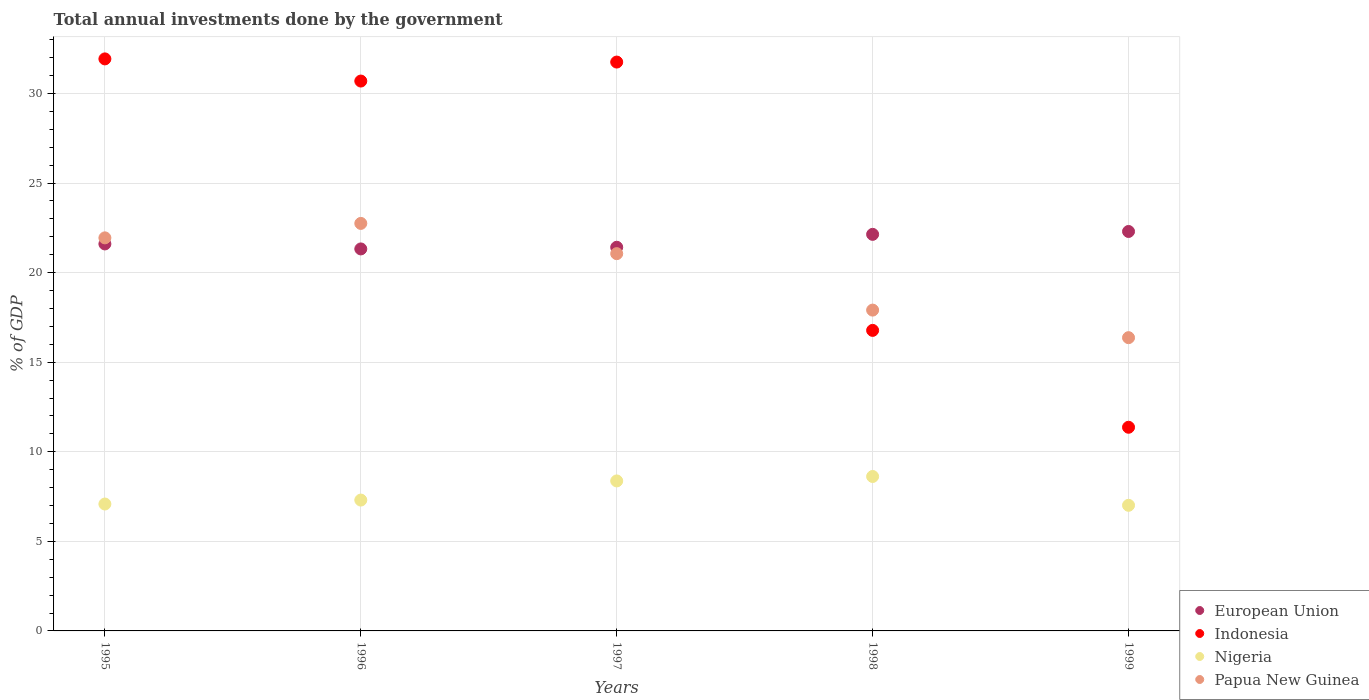How many different coloured dotlines are there?
Your answer should be compact. 4. What is the total annual investments done by the government in Indonesia in 1999?
Offer a terse response. 11.37. Across all years, what is the maximum total annual investments done by the government in European Union?
Offer a terse response. 22.3. Across all years, what is the minimum total annual investments done by the government in Nigeria?
Give a very brief answer. 7.01. In which year was the total annual investments done by the government in Papua New Guinea maximum?
Offer a terse response. 1996. In which year was the total annual investments done by the government in Papua New Guinea minimum?
Provide a short and direct response. 1999. What is the total total annual investments done by the government in Indonesia in the graph?
Your response must be concise. 122.51. What is the difference between the total annual investments done by the government in Papua New Guinea in 1996 and that in 1998?
Make the answer very short. 4.84. What is the difference between the total annual investments done by the government in European Union in 1995 and the total annual investments done by the government in Nigeria in 1999?
Your answer should be compact. 14.59. What is the average total annual investments done by the government in Nigeria per year?
Provide a short and direct response. 7.68. In the year 1996, what is the difference between the total annual investments done by the government in European Union and total annual investments done by the government in Nigeria?
Offer a terse response. 14.02. What is the ratio of the total annual investments done by the government in Indonesia in 1997 to that in 1998?
Offer a terse response. 1.89. Is the difference between the total annual investments done by the government in European Union in 1995 and 1997 greater than the difference between the total annual investments done by the government in Nigeria in 1995 and 1997?
Give a very brief answer. Yes. What is the difference between the highest and the second highest total annual investments done by the government in Indonesia?
Give a very brief answer. 0.18. What is the difference between the highest and the lowest total annual investments done by the government in Indonesia?
Give a very brief answer. 20.56. In how many years, is the total annual investments done by the government in European Union greater than the average total annual investments done by the government in European Union taken over all years?
Provide a succinct answer. 2. Is it the case that in every year, the sum of the total annual investments done by the government in Indonesia and total annual investments done by the government in Papua New Guinea  is greater than the total annual investments done by the government in European Union?
Your answer should be very brief. Yes. Does the total annual investments done by the government in European Union monotonically increase over the years?
Ensure brevity in your answer.  No. Is the total annual investments done by the government in European Union strictly greater than the total annual investments done by the government in Nigeria over the years?
Offer a terse response. Yes. Is the total annual investments done by the government in Indonesia strictly less than the total annual investments done by the government in Nigeria over the years?
Make the answer very short. No. How many dotlines are there?
Offer a terse response. 4. How many years are there in the graph?
Provide a short and direct response. 5. What is the difference between two consecutive major ticks on the Y-axis?
Your answer should be very brief. 5. Where does the legend appear in the graph?
Make the answer very short. Bottom right. What is the title of the graph?
Offer a terse response. Total annual investments done by the government. Does "Brunei Darussalam" appear as one of the legend labels in the graph?
Make the answer very short. No. What is the label or title of the Y-axis?
Your answer should be compact. % of GDP. What is the % of GDP in European Union in 1995?
Give a very brief answer. 21.6. What is the % of GDP in Indonesia in 1995?
Keep it short and to the point. 31.93. What is the % of GDP of Nigeria in 1995?
Keep it short and to the point. 7.08. What is the % of GDP of Papua New Guinea in 1995?
Give a very brief answer. 21.94. What is the % of GDP in European Union in 1996?
Your response must be concise. 21.32. What is the % of GDP of Indonesia in 1996?
Offer a terse response. 30.69. What is the % of GDP of Nigeria in 1996?
Keep it short and to the point. 7.3. What is the % of GDP in Papua New Guinea in 1996?
Your answer should be very brief. 22.75. What is the % of GDP in European Union in 1997?
Your answer should be compact. 21.41. What is the % of GDP in Indonesia in 1997?
Make the answer very short. 31.75. What is the % of GDP of Nigeria in 1997?
Offer a terse response. 8.37. What is the % of GDP in Papua New Guinea in 1997?
Make the answer very short. 21.06. What is the % of GDP in European Union in 1998?
Your answer should be very brief. 22.13. What is the % of GDP of Indonesia in 1998?
Provide a succinct answer. 16.77. What is the % of GDP in Nigeria in 1998?
Give a very brief answer. 8.62. What is the % of GDP of Papua New Guinea in 1998?
Offer a very short reply. 17.91. What is the % of GDP of European Union in 1999?
Give a very brief answer. 22.3. What is the % of GDP of Indonesia in 1999?
Keep it short and to the point. 11.37. What is the % of GDP of Nigeria in 1999?
Offer a very short reply. 7.01. What is the % of GDP of Papua New Guinea in 1999?
Keep it short and to the point. 16.37. Across all years, what is the maximum % of GDP of European Union?
Make the answer very short. 22.3. Across all years, what is the maximum % of GDP in Indonesia?
Provide a succinct answer. 31.93. Across all years, what is the maximum % of GDP of Nigeria?
Your answer should be compact. 8.62. Across all years, what is the maximum % of GDP of Papua New Guinea?
Ensure brevity in your answer.  22.75. Across all years, what is the minimum % of GDP of European Union?
Give a very brief answer. 21.32. Across all years, what is the minimum % of GDP in Indonesia?
Make the answer very short. 11.37. Across all years, what is the minimum % of GDP of Nigeria?
Offer a very short reply. 7.01. Across all years, what is the minimum % of GDP of Papua New Guinea?
Ensure brevity in your answer.  16.37. What is the total % of GDP of European Union in the graph?
Make the answer very short. 108.77. What is the total % of GDP of Indonesia in the graph?
Provide a succinct answer. 122.51. What is the total % of GDP in Nigeria in the graph?
Give a very brief answer. 38.39. What is the total % of GDP of Papua New Guinea in the graph?
Provide a short and direct response. 100.02. What is the difference between the % of GDP of European Union in 1995 and that in 1996?
Offer a terse response. 0.28. What is the difference between the % of GDP in Indonesia in 1995 and that in 1996?
Offer a very short reply. 1.24. What is the difference between the % of GDP of Nigeria in 1995 and that in 1996?
Ensure brevity in your answer.  -0.22. What is the difference between the % of GDP in Papua New Guinea in 1995 and that in 1996?
Provide a short and direct response. -0.81. What is the difference between the % of GDP in European Union in 1995 and that in 1997?
Offer a very short reply. 0.19. What is the difference between the % of GDP in Indonesia in 1995 and that in 1997?
Offer a terse response. 0.18. What is the difference between the % of GDP of Nigeria in 1995 and that in 1997?
Keep it short and to the point. -1.29. What is the difference between the % of GDP in Papua New Guinea in 1995 and that in 1997?
Give a very brief answer. 0.88. What is the difference between the % of GDP of European Union in 1995 and that in 1998?
Give a very brief answer. -0.53. What is the difference between the % of GDP in Indonesia in 1995 and that in 1998?
Make the answer very short. 15.15. What is the difference between the % of GDP in Nigeria in 1995 and that in 1998?
Provide a short and direct response. -1.54. What is the difference between the % of GDP in Papua New Guinea in 1995 and that in 1998?
Your answer should be very brief. 4.03. What is the difference between the % of GDP in European Union in 1995 and that in 1999?
Your response must be concise. -0.7. What is the difference between the % of GDP of Indonesia in 1995 and that in 1999?
Provide a short and direct response. 20.56. What is the difference between the % of GDP in Nigeria in 1995 and that in 1999?
Offer a terse response. 0.07. What is the difference between the % of GDP in Papua New Guinea in 1995 and that in 1999?
Give a very brief answer. 5.57. What is the difference between the % of GDP in European Union in 1996 and that in 1997?
Your response must be concise. -0.09. What is the difference between the % of GDP in Indonesia in 1996 and that in 1997?
Your answer should be compact. -1.06. What is the difference between the % of GDP of Nigeria in 1996 and that in 1997?
Your response must be concise. -1.07. What is the difference between the % of GDP of Papua New Guinea in 1996 and that in 1997?
Provide a short and direct response. 1.69. What is the difference between the % of GDP in European Union in 1996 and that in 1998?
Keep it short and to the point. -0.81. What is the difference between the % of GDP of Indonesia in 1996 and that in 1998?
Make the answer very short. 13.92. What is the difference between the % of GDP in Nigeria in 1996 and that in 1998?
Make the answer very short. -1.32. What is the difference between the % of GDP of Papua New Guinea in 1996 and that in 1998?
Provide a succinct answer. 4.84. What is the difference between the % of GDP in European Union in 1996 and that in 1999?
Provide a short and direct response. -0.97. What is the difference between the % of GDP in Indonesia in 1996 and that in 1999?
Make the answer very short. 19.32. What is the difference between the % of GDP in Nigeria in 1996 and that in 1999?
Keep it short and to the point. 0.29. What is the difference between the % of GDP of Papua New Guinea in 1996 and that in 1999?
Offer a terse response. 6.38. What is the difference between the % of GDP in European Union in 1997 and that in 1998?
Your answer should be compact. -0.72. What is the difference between the % of GDP of Indonesia in 1997 and that in 1998?
Offer a very short reply. 14.98. What is the difference between the % of GDP in Nigeria in 1997 and that in 1998?
Ensure brevity in your answer.  -0.25. What is the difference between the % of GDP in Papua New Guinea in 1997 and that in 1998?
Give a very brief answer. 3.15. What is the difference between the % of GDP in European Union in 1997 and that in 1999?
Your response must be concise. -0.88. What is the difference between the % of GDP in Indonesia in 1997 and that in 1999?
Your response must be concise. 20.38. What is the difference between the % of GDP in Nigeria in 1997 and that in 1999?
Your answer should be compact. 1.36. What is the difference between the % of GDP of Papua New Guinea in 1997 and that in 1999?
Make the answer very short. 4.69. What is the difference between the % of GDP of European Union in 1998 and that in 1999?
Offer a very short reply. -0.16. What is the difference between the % of GDP of Indonesia in 1998 and that in 1999?
Make the answer very short. 5.41. What is the difference between the % of GDP in Nigeria in 1998 and that in 1999?
Provide a short and direct response. 1.61. What is the difference between the % of GDP of Papua New Guinea in 1998 and that in 1999?
Ensure brevity in your answer.  1.54. What is the difference between the % of GDP in European Union in 1995 and the % of GDP in Indonesia in 1996?
Make the answer very short. -9.09. What is the difference between the % of GDP in European Union in 1995 and the % of GDP in Nigeria in 1996?
Offer a very short reply. 14.3. What is the difference between the % of GDP in European Union in 1995 and the % of GDP in Papua New Guinea in 1996?
Ensure brevity in your answer.  -1.15. What is the difference between the % of GDP of Indonesia in 1995 and the % of GDP of Nigeria in 1996?
Keep it short and to the point. 24.62. What is the difference between the % of GDP of Indonesia in 1995 and the % of GDP of Papua New Guinea in 1996?
Your answer should be very brief. 9.18. What is the difference between the % of GDP of Nigeria in 1995 and the % of GDP of Papua New Guinea in 1996?
Provide a short and direct response. -15.66. What is the difference between the % of GDP of European Union in 1995 and the % of GDP of Indonesia in 1997?
Your answer should be compact. -10.15. What is the difference between the % of GDP in European Union in 1995 and the % of GDP in Nigeria in 1997?
Keep it short and to the point. 13.23. What is the difference between the % of GDP of European Union in 1995 and the % of GDP of Papua New Guinea in 1997?
Keep it short and to the point. 0.54. What is the difference between the % of GDP in Indonesia in 1995 and the % of GDP in Nigeria in 1997?
Ensure brevity in your answer.  23.56. What is the difference between the % of GDP of Indonesia in 1995 and the % of GDP of Papua New Guinea in 1997?
Your answer should be compact. 10.87. What is the difference between the % of GDP of Nigeria in 1995 and the % of GDP of Papua New Guinea in 1997?
Keep it short and to the point. -13.97. What is the difference between the % of GDP of European Union in 1995 and the % of GDP of Indonesia in 1998?
Keep it short and to the point. 4.82. What is the difference between the % of GDP of European Union in 1995 and the % of GDP of Nigeria in 1998?
Give a very brief answer. 12.98. What is the difference between the % of GDP in European Union in 1995 and the % of GDP in Papua New Guinea in 1998?
Offer a very short reply. 3.69. What is the difference between the % of GDP of Indonesia in 1995 and the % of GDP of Nigeria in 1998?
Provide a short and direct response. 23.31. What is the difference between the % of GDP of Indonesia in 1995 and the % of GDP of Papua New Guinea in 1998?
Your answer should be compact. 14.02. What is the difference between the % of GDP of Nigeria in 1995 and the % of GDP of Papua New Guinea in 1998?
Your answer should be very brief. -10.82. What is the difference between the % of GDP of European Union in 1995 and the % of GDP of Indonesia in 1999?
Provide a succinct answer. 10.23. What is the difference between the % of GDP of European Union in 1995 and the % of GDP of Nigeria in 1999?
Your answer should be very brief. 14.59. What is the difference between the % of GDP of European Union in 1995 and the % of GDP of Papua New Guinea in 1999?
Offer a terse response. 5.23. What is the difference between the % of GDP in Indonesia in 1995 and the % of GDP in Nigeria in 1999?
Your answer should be very brief. 24.92. What is the difference between the % of GDP in Indonesia in 1995 and the % of GDP in Papua New Guinea in 1999?
Give a very brief answer. 15.56. What is the difference between the % of GDP of Nigeria in 1995 and the % of GDP of Papua New Guinea in 1999?
Offer a very short reply. -9.29. What is the difference between the % of GDP in European Union in 1996 and the % of GDP in Indonesia in 1997?
Offer a very short reply. -10.43. What is the difference between the % of GDP of European Union in 1996 and the % of GDP of Nigeria in 1997?
Offer a terse response. 12.95. What is the difference between the % of GDP of European Union in 1996 and the % of GDP of Papua New Guinea in 1997?
Ensure brevity in your answer.  0.26. What is the difference between the % of GDP of Indonesia in 1996 and the % of GDP of Nigeria in 1997?
Your answer should be compact. 22.32. What is the difference between the % of GDP of Indonesia in 1996 and the % of GDP of Papua New Guinea in 1997?
Make the answer very short. 9.63. What is the difference between the % of GDP of Nigeria in 1996 and the % of GDP of Papua New Guinea in 1997?
Make the answer very short. -13.75. What is the difference between the % of GDP in European Union in 1996 and the % of GDP in Indonesia in 1998?
Ensure brevity in your answer.  4.55. What is the difference between the % of GDP of European Union in 1996 and the % of GDP of Nigeria in 1998?
Provide a short and direct response. 12.7. What is the difference between the % of GDP in European Union in 1996 and the % of GDP in Papua New Guinea in 1998?
Your response must be concise. 3.41. What is the difference between the % of GDP in Indonesia in 1996 and the % of GDP in Nigeria in 1998?
Your response must be concise. 22.07. What is the difference between the % of GDP in Indonesia in 1996 and the % of GDP in Papua New Guinea in 1998?
Provide a short and direct response. 12.78. What is the difference between the % of GDP in Nigeria in 1996 and the % of GDP in Papua New Guinea in 1998?
Give a very brief answer. -10.6. What is the difference between the % of GDP in European Union in 1996 and the % of GDP in Indonesia in 1999?
Offer a very short reply. 9.95. What is the difference between the % of GDP in European Union in 1996 and the % of GDP in Nigeria in 1999?
Provide a succinct answer. 14.31. What is the difference between the % of GDP of European Union in 1996 and the % of GDP of Papua New Guinea in 1999?
Make the answer very short. 4.95. What is the difference between the % of GDP of Indonesia in 1996 and the % of GDP of Nigeria in 1999?
Your answer should be very brief. 23.68. What is the difference between the % of GDP in Indonesia in 1996 and the % of GDP in Papua New Guinea in 1999?
Offer a terse response. 14.32. What is the difference between the % of GDP in Nigeria in 1996 and the % of GDP in Papua New Guinea in 1999?
Your answer should be compact. -9.06. What is the difference between the % of GDP of European Union in 1997 and the % of GDP of Indonesia in 1998?
Your answer should be compact. 4.64. What is the difference between the % of GDP of European Union in 1997 and the % of GDP of Nigeria in 1998?
Your answer should be compact. 12.79. What is the difference between the % of GDP in European Union in 1997 and the % of GDP in Papua New Guinea in 1998?
Make the answer very short. 3.51. What is the difference between the % of GDP in Indonesia in 1997 and the % of GDP in Nigeria in 1998?
Make the answer very short. 23.13. What is the difference between the % of GDP in Indonesia in 1997 and the % of GDP in Papua New Guinea in 1998?
Your answer should be compact. 13.84. What is the difference between the % of GDP of Nigeria in 1997 and the % of GDP of Papua New Guinea in 1998?
Keep it short and to the point. -9.53. What is the difference between the % of GDP of European Union in 1997 and the % of GDP of Indonesia in 1999?
Offer a terse response. 10.05. What is the difference between the % of GDP of European Union in 1997 and the % of GDP of Nigeria in 1999?
Your answer should be very brief. 14.4. What is the difference between the % of GDP in European Union in 1997 and the % of GDP in Papua New Guinea in 1999?
Your response must be concise. 5.05. What is the difference between the % of GDP of Indonesia in 1997 and the % of GDP of Nigeria in 1999?
Offer a very short reply. 24.74. What is the difference between the % of GDP in Indonesia in 1997 and the % of GDP in Papua New Guinea in 1999?
Offer a very short reply. 15.38. What is the difference between the % of GDP of Nigeria in 1997 and the % of GDP of Papua New Guinea in 1999?
Your response must be concise. -8. What is the difference between the % of GDP in European Union in 1998 and the % of GDP in Indonesia in 1999?
Provide a succinct answer. 10.77. What is the difference between the % of GDP in European Union in 1998 and the % of GDP in Nigeria in 1999?
Offer a very short reply. 15.12. What is the difference between the % of GDP of European Union in 1998 and the % of GDP of Papua New Guinea in 1999?
Give a very brief answer. 5.77. What is the difference between the % of GDP of Indonesia in 1998 and the % of GDP of Nigeria in 1999?
Ensure brevity in your answer.  9.76. What is the difference between the % of GDP in Indonesia in 1998 and the % of GDP in Papua New Guinea in 1999?
Give a very brief answer. 0.41. What is the difference between the % of GDP of Nigeria in 1998 and the % of GDP of Papua New Guinea in 1999?
Ensure brevity in your answer.  -7.75. What is the average % of GDP in European Union per year?
Your response must be concise. 21.75. What is the average % of GDP in Indonesia per year?
Make the answer very short. 24.5. What is the average % of GDP of Nigeria per year?
Provide a succinct answer. 7.68. What is the average % of GDP in Papua New Guinea per year?
Offer a very short reply. 20. In the year 1995, what is the difference between the % of GDP of European Union and % of GDP of Indonesia?
Offer a very short reply. -10.33. In the year 1995, what is the difference between the % of GDP of European Union and % of GDP of Nigeria?
Offer a terse response. 14.52. In the year 1995, what is the difference between the % of GDP in European Union and % of GDP in Papua New Guinea?
Keep it short and to the point. -0.34. In the year 1995, what is the difference between the % of GDP in Indonesia and % of GDP in Nigeria?
Offer a terse response. 24.84. In the year 1995, what is the difference between the % of GDP of Indonesia and % of GDP of Papua New Guinea?
Ensure brevity in your answer.  9.99. In the year 1995, what is the difference between the % of GDP of Nigeria and % of GDP of Papua New Guinea?
Your answer should be very brief. -14.86. In the year 1996, what is the difference between the % of GDP in European Union and % of GDP in Indonesia?
Offer a terse response. -9.37. In the year 1996, what is the difference between the % of GDP in European Union and % of GDP in Nigeria?
Ensure brevity in your answer.  14.02. In the year 1996, what is the difference between the % of GDP of European Union and % of GDP of Papua New Guinea?
Offer a terse response. -1.42. In the year 1996, what is the difference between the % of GDP in Indonesia and % of GDP in Nigeria?
Make the answer very short. 23.39. In the year 1996, what is the difference between the % of GDP in Indonesia and % of GDP in Papua New Guinea?
Ensure brevity in your answer.  7.95. In the year 1996, what is the difference between the % of GDP of Nigeria and % of GDP of Papua New Guinea?
Provide a succinct answer. -15.44. In the year 1997, what is the difference between the % of GDP in European Union and % of GDP in Indonesia?
Provide a succinct answer. -10.34. In the year 1997, what is the difference between the % of GDP of European Union and % of GDP of Nigeria?
Provide a short and direct response. 13.04. In the year 1997, what is the difference between the % of GDP of European Union and % of GDP of Papua New Guinea?
Provide a succinct answer. 0.36. In the year 1997, what is the difference between the % of GDP in Indonesia and % of GDP in Nigeria?
Give a very brief answer. 23.38. In the year 1997, what is the difference between the % of GDP of Indonesia and % of GDP of Papua New Guinea?
Keep it short and to the point. 10.69. In the year 1997, what is the difference between the % of GDP in Nigeria and % of GDP in Papua New Guinea?
Give a very brief answer. -12.69. In the year 1998, what is the difference between the % of GDP of European Union and % of GDP of Indonesia?
Provide a short and direct response. 5.36. In the year 1998, what is the difference between the % of GDP of European Union and % of GDP of Nigeria?
Your response must be concise. 13.51. In the year 1998, what is the difference between the % of GDP in European Union and % of GDP in Papua New Guinea?
Give a very brief answer. 4.23. In the year 1998, what is the difference between the % of GDP in Indonesia and % of GDP in Nigeria?
Ensure brevity in your answer.  8.16. In the year 1998, what is the difference between the % of GDP of Indonesia and % of GDP of Papua New Guinea?
Offer a very short reply. -1.13. In the year 1998, what is the difference between the % of GDP in Nigeria and % of GDP in Papua New Guinea?
Your response must be concise. -9.29. In the year 1999, what is the difference between the % of GDP of European Union and % of GDP of Indonesia?
Your response must be concise. 10.93. In the year 1999, what is the difference between the % of GDP of European Union and % of GDP of Nigeria?
Offer a terse response. 15.28. In the year 1999, what is the difference between the % of GDP in European Union and % of GDP in Papua New Guinea?
Keep it short and to the point. 5.93. In the year 1999, what is the difference between the % of GDP in Indonesia and % of GDP in Nigeria?
Your answer should be compact. 4.36. In the year 1999, what is the difference between the % of GDP of Indonesia and % of GDP of Papua New Guinea?
Your response must be concise. -5. In the year 1999, what is the difference between the % of GDP in Nigeria and % of GDP in Papua New Guinea?
Give a very brief answer. -9.36. What is the ratio of the % of GDP of European Union in 1995 to that in 1996?
Give a very brief answer. 1.01. What is the ratio of the % of GDP in Indonesia in 1995 to that in 1996?
Offer a terse response. 1.04. What is the ratio of the % of GDP in Nigeria in 1995 to that in 1996?
Your answer should be compact. 0.97. What is the ratio of the % of GDP of Papua New Guinea in 1995 to that in 1996?
Make the answer very short. 0.96. What is the ratio of the % of GDP of European Union in 1995 to that in 1997?
Make the answer very short. 1.01. What is the ratio of the % of GDP of Indonesia in 1995 to that in 1997?
Provide a succinct answer. 1.01. What is the ratio of the % of GDP of Nigeria in 1995 to that in 1997?
Provide a short and direct response. 0.85. What is the ratio of the % of GDP of Papua New Guinea in 1995 to that in 1997?
Your response must be concise. 1.04. What is the ratio of the % of GDP of European Union in 1995 to that in 1998?
Offer a terse response. 0.98. What is the ratio of the % of GDP in Indonesia in 1995 to that in 1998?
Ensure brevity in your answer.  1.9. What is the ratio of the % of GDP in Nigeria in 1995 to that in 1998?
Make the answer very short. 0.82. What is the ratio of the % of GDP of Papua New Guinea in 1995 to that in 1998?
Offer a very short reply. 1.23. What is the ratio of the % of GDP of European Union in 1995 to that in 1999?
Give a very brief answer. 0.97. What is the ratio of the % of GDP of Indonesia in 1995 to that in 1999?
Provide a succinct answer. 2.81. What is the ratio of the % of GDP of Nigeria in 1995 to that in 1999?
Your answer should be very brief. 1.01. What is the ratio of the % of GDP in Papua New Guinea in 1995 to that in 1999?
Your answer should be very brief. 1.34. What is the ratio of the % of GDP of European Union in 1996 to that in 1997?
Provide a succinct answer. 1. What is the ratio of the % of GDP of Indonesia in 1996 to that in 1997?
Provide a short and direct response. 0.97. What is the ratio of the % of GDP of Nigeria in 1996 to that in 1997?
Your response must be concise. 0.87. What is the ratio of the % of GDP in Papua New Guinea in 1996 to that in 1997?
Your response must be concise. 1.08. What is the ratio of the % of GDP in European Union in 1996 to that in 1998?
Your answer should be compact. 0.96. What is the ratio of the % of GDP of Indonesia in 1996 to that in 1998?
Make the answer very short. 1.83. What is the ratio of the % of GDP of Nigeria in 1996 to that in 1998?
Provide a succinct answer. 0.85. What is the ratio of the % of GDP of Papua New Guinea in 1996 to that in 1998?
Provide a short and direct response. 1.27. What is the ratio of the % of GDP of European Union in 1996 to that in 1999?
Ensure brevity in your answer.  0.96. What is the ratio of the % of GDP of Nigeria in 1996 to that in 1999?
Make the answer very short. 1.04. What is the ratio of the % of GDP of Papua New Guinea in 1996 to that in 1999?
Offer a very short reply. 1.39. What is the ratio of the % of GDP of European Union in 1997 to that in 1998?
Offer a very short reply. 0.97. What is the ratio of the % of GDP in Indonesia in 1997 to that in 1998?
Your answer should be compact. 1.89. What is the ratio of the % of GDP of Nigeria in 1997 to that in 1998?
Your answer should be very brief. 0.97. What is the ratio of the % of GDP in Papua New Guinea in 1997 to that in 1998?
Give a very brief answer. 1.18. What is the ratio of the % of GDP in European Union in 1997 to that in 1999?
Make the answer very short. 0.96. What is the ratio of the % of GDP in Indonesia in 1997 to that in 1999?
Offer a very short reply. 2.79. What is the ratio of the % of GDP in Nigeria in 1997 to that in 1999?
Offer a terse response. 1.19. What is the ratio of the % of GDP in Papua New Guinea in 1997 to that in 1999?
Keep it short and to the point. 1.29. What is the ratio of the % of GDP in Indonesia in 1998 to that in 1999?
Ensure brevity in your answer.  1.48. What is the ratio of the % of GDP of Nigeria in 1998 to that in 1999?
Your answer should be compact. 1.23. What is the ratio of the % of GDP in Papua New Guinea in 1998 to that in 1999?
Give a very brief answer. 1.09. What is the difference between the highest and the second highest % of GDP in European Union?
Ensure brevity in your answer.  0.16. What is the difference between the highest and the second highest % of GDP in Indonesia?
Your answer should be very brief. 0.18. What is the difference between the highest and the second highest % of GDP of Nigeria?
Offer a very short reply. 0.25. What is the difference between the highest and the second highest % of GDP in Papua New Guinea?
Offer a terse response. 0.81. What is the difference between the highest and the lowest % of GDP in European Union?
Keep it short and to the point. 0.97. What is the difference between the highest and the lowest % of GDP in Indonesia?
Your answer should be very brief. 20.56. What is the difference between the highest and the lowest % of GDP of Nigeria?
Offer a very short reply. 1.61. What is the difference between the highest and the lowest % of GDP of Papua New Guinea?
Your response must be concise. 6.38. 